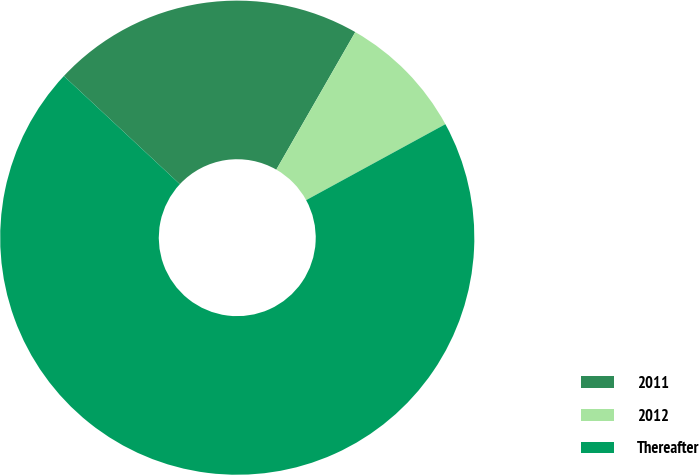Convert chart. <chart><loc_0><loc_0><loc_500><loc_500><pie_chart><fcel>2011<fcel>2012<fcel>Thereafter<nl><fcel>21.35%<fcel>8.76%<fcel>69.89%<nl></chart> 